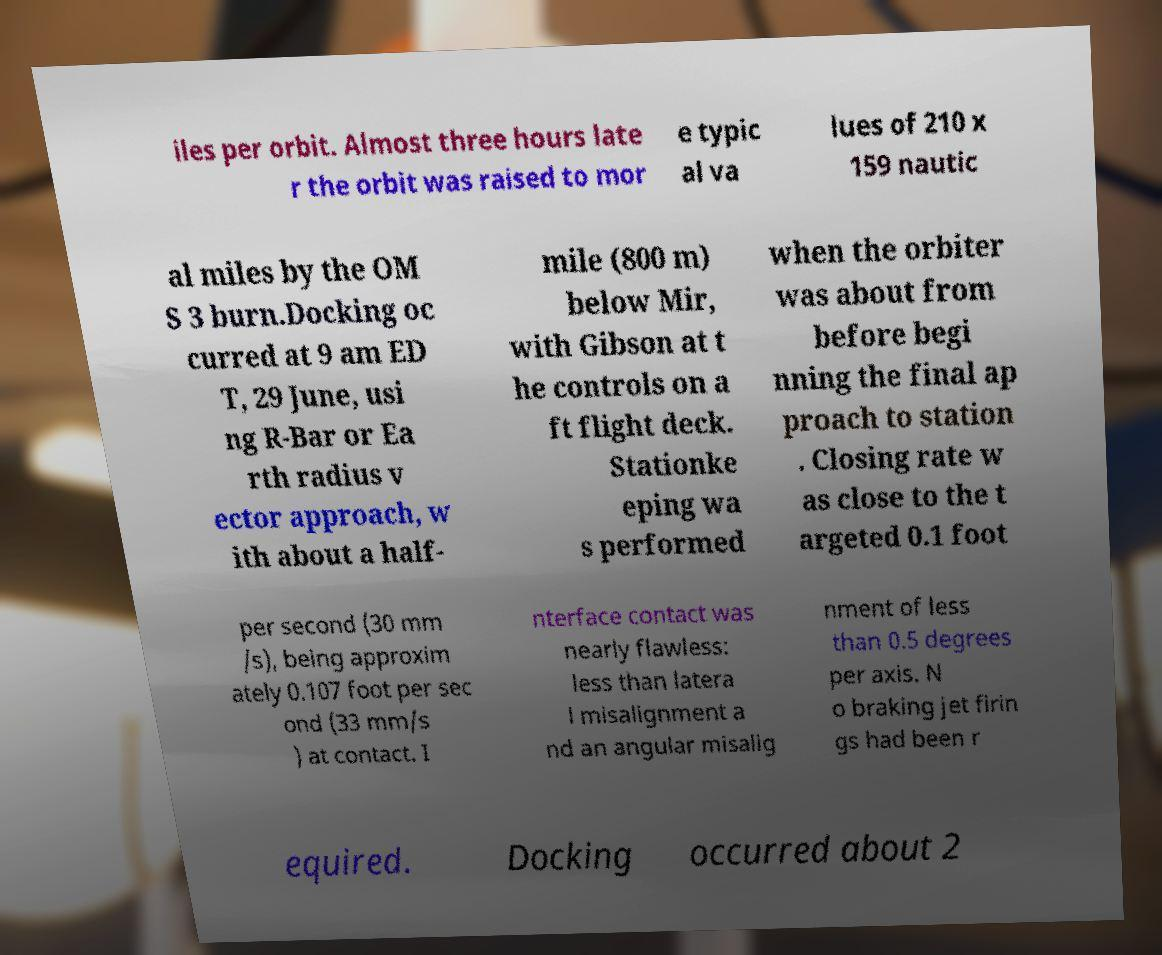For documentation purposes, I need the text within this image transcribed. Could you provide that? iles per orbit. Almost three hours late r the orbit was raised to mor e typic al va lues of 210 x 159 nautic al miles by the OM S 3 burn.Docking oc curred at 9 am ED T, 29 June, usi ng R-Bar or Ea rth radius v ector approach, w ith about a half- mile (800 m) below Mir, with Gibson at t he controls on a ft flight deck. Stationke eping wa s performed when the orbiter was about from before begi nning the final ap proach to station . Closing rate w as close to the t argeted 0.1 foot per second (30 mm /s), being approxim ately 0.107 foot per sec ond (33 mm/s ) at contact. I nterface contact was nearly flawless: less than latera l misalignment a nd an angular misalig nment of less than 0.5 degrees per axis. N o braking jet firin gs had been r equired. Docking occurred about 2 